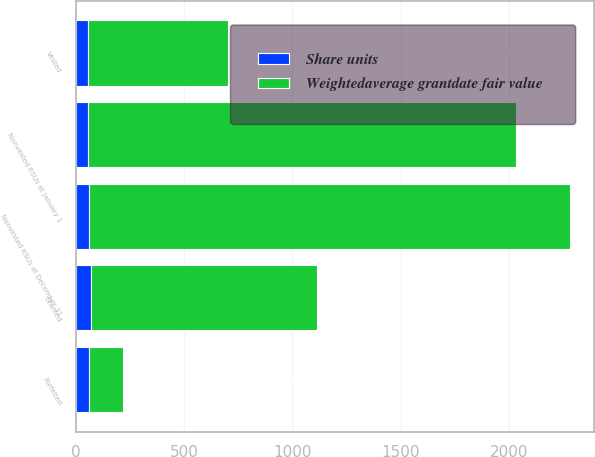Convert chart to OTSL. <chart><loc_0><loc_0><loc_500><loc_500><stacked_bar_chart><ecel><fcel>Nonvested RSUs at January 1<fcel>Granted<fcel>Vested<fcel>Forfeited<fcel>Nonvested RSUs at December 31<nl><fcel>Weightedaverage grantdate fair value<fcel>1979<fcel>1043<fcel>647<fcel>157<fcel>2218<nl><fcel>Share units<fcel>55.36<fcel>70.09<fcel>54.96<fcel>60.55<fcel>62.06<nl></chart> 